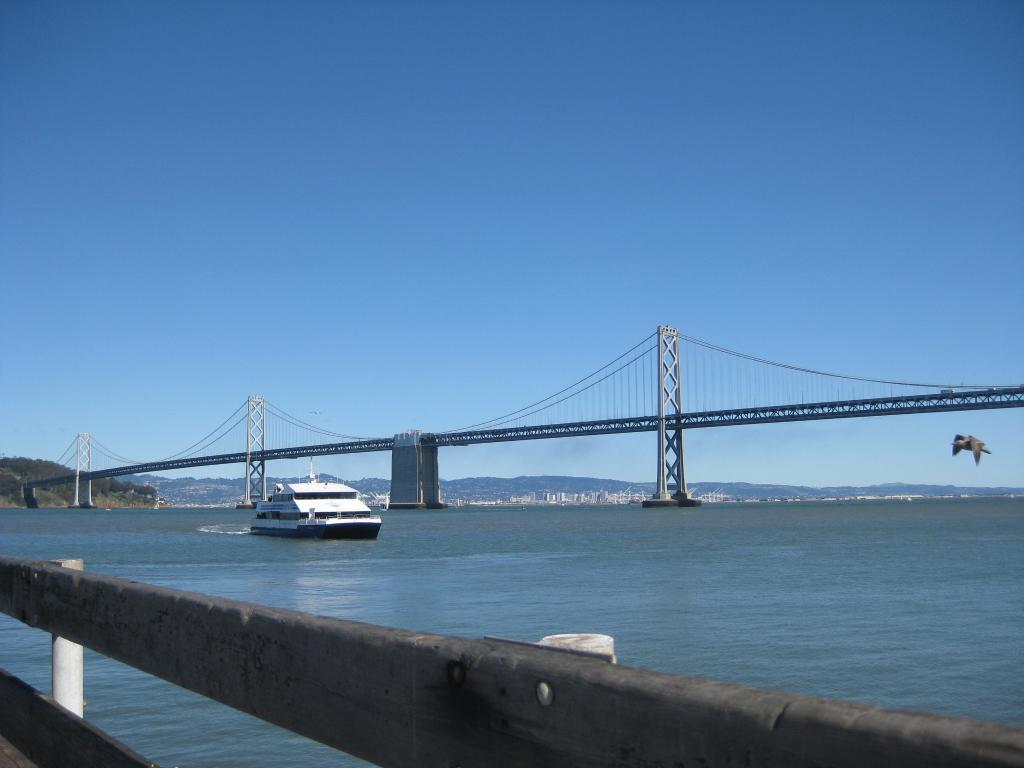What is the main subject of the image? The main subject of the image is a boat. Where is the boat located? The boat is on the water. What can be seen in the background of the image? There is a bridge and a bird in the air in the background of the image. What part of the natural environment is visible in the image? The sky is visible in the image. What type of agreement is being signed by the bird in the image? There is no bird signing any agreement in the image; it is simply flying in the air. Is there a mask visible on the boat in the image? There is no mask present on the boat or any other part of the image. 